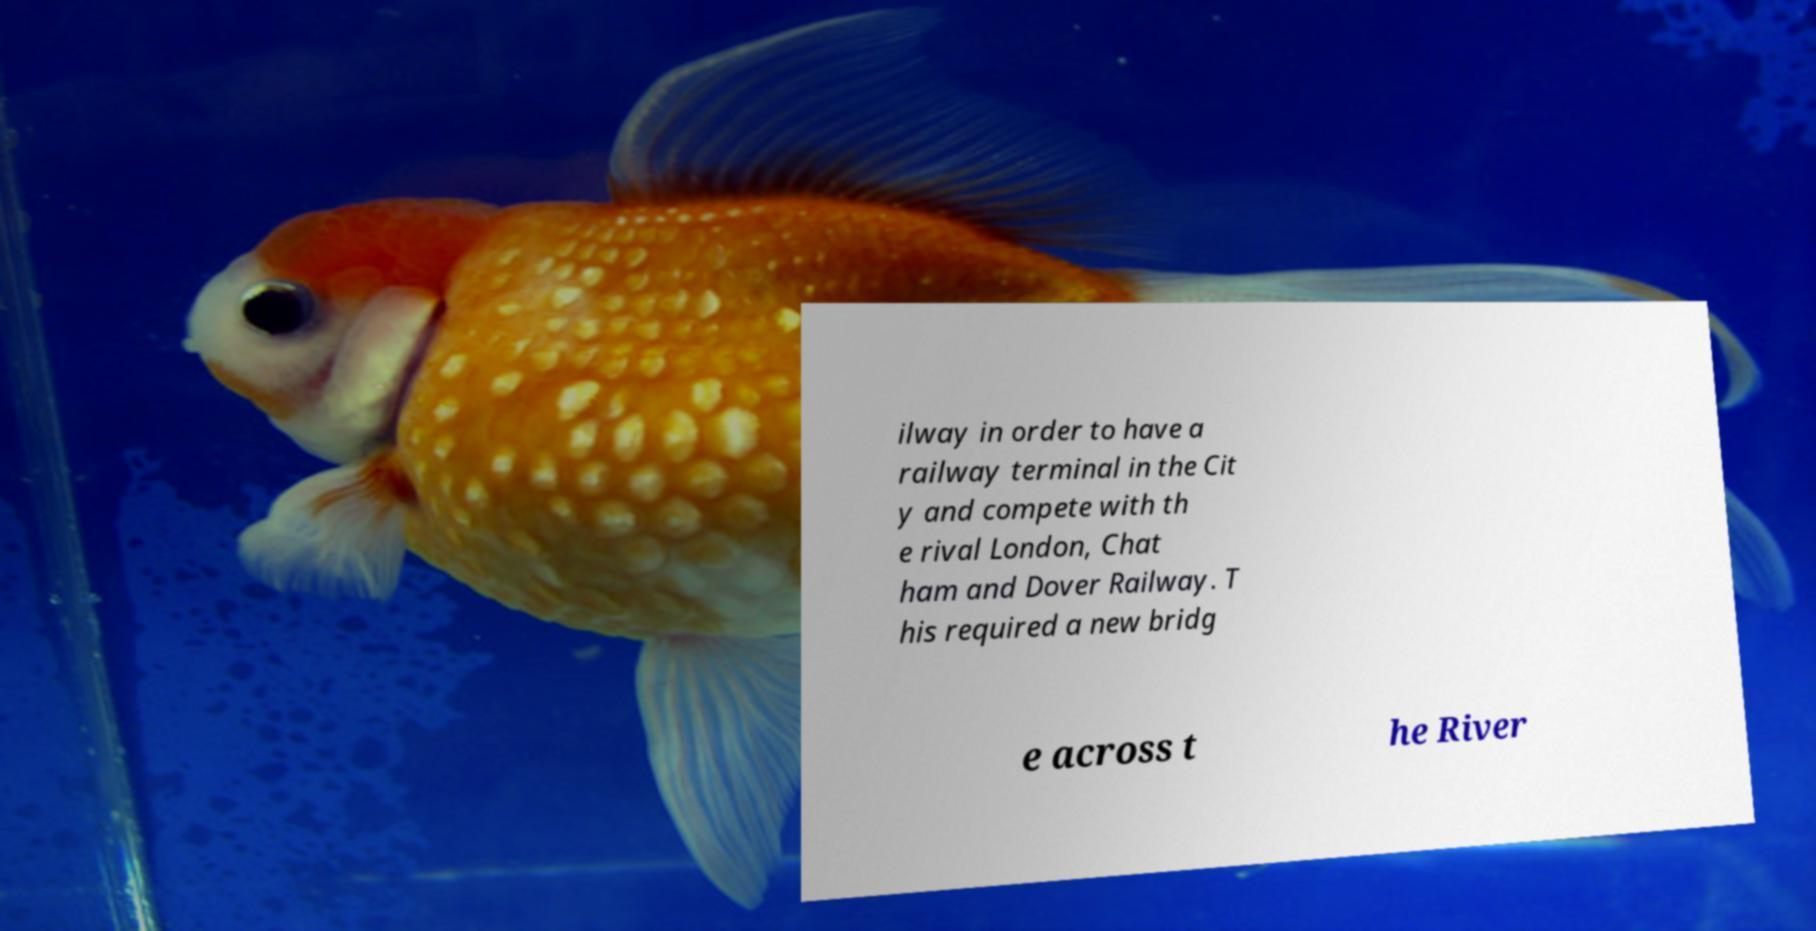What messages or text are displayed in this image? I need them in a readable, typed format. ilway in order to have a railway terminal in the Cit y and compete with th e rival London, Chat ham and Dover Railway. T his required a new bridg e across t he River 